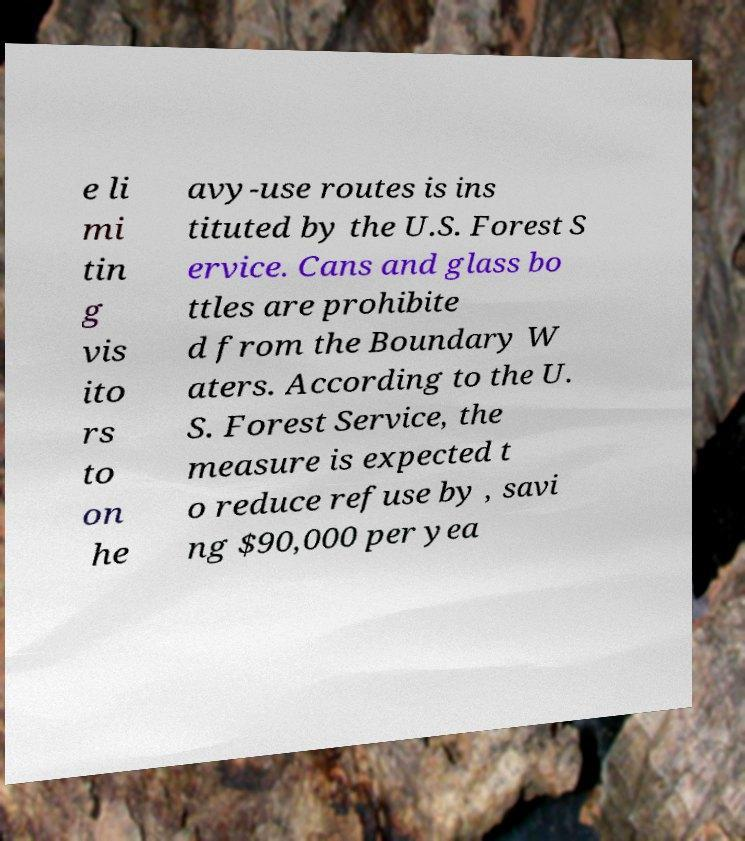Could you assist in decoding the text presented in this image and type it out clearly? e li mi tin g vis ito rs to on he avy-use routes is ins tituted by the U.S. Forest S ervice. Cans and glass bo ttles are prohibite d from the Boundary W aters. According to the U. S. Forest Service, the measure is expected t o reduce refuse by , savi ng $90,000 per yea 